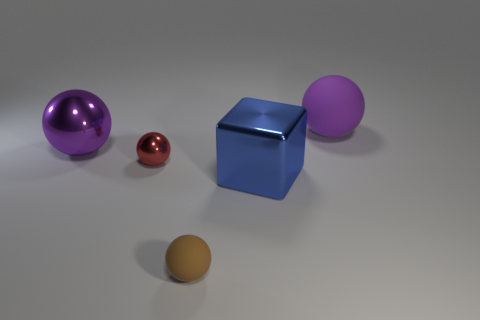There is a large shiny thing that is the same color as the big rubber thing; what is its shape?
Your answer should be compact. Sphere. Is there a tiny green cylinder that has the same material as the big blue block?
Your response must be concise. No. Do the blue thing and the large purple ball behind the big purple metallic object have the same material?
Your answer should be compact. No. There is a matte object that is the same size as the purple metal thing; what color is it?
Ensure brevity in your answer.  Purple. There is a metal thing right of the small sphere behind the tiny matte thing; how big is it?
Offer a terse response. Large. Does the large rubber sphere have the same color as the tiny sphere behind the brown thing?
Ensure brevity in your answer.  No. Is the number of small brown things behind the small matte sphere less than the number of large red cylinders?
Provide a succinct answer. No. What number of other objects are the same size as the red metallic object?
Your answer should be compact. 1. Do the metallic thing to the right of the small brown sphere and the small red thing have the same shape?
Your response must be concise. No. Is the number of big balls in front of the purple shiny thing greater than the number of tiny cyan cylinders?
Keep it short and to the point. No. 